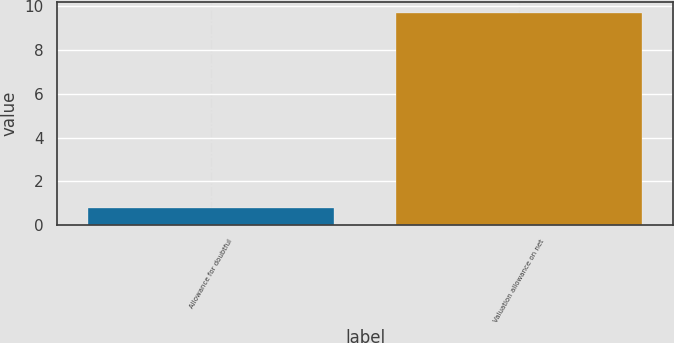Convert chart. <chart><loc_0><loc_0><loc_500><loc_500><bar_chart><fcel>Allowance for doubtful<fcel>Valuation allowance on net<nl><fcel>0.8<fcel>9.7<nl></chart> 